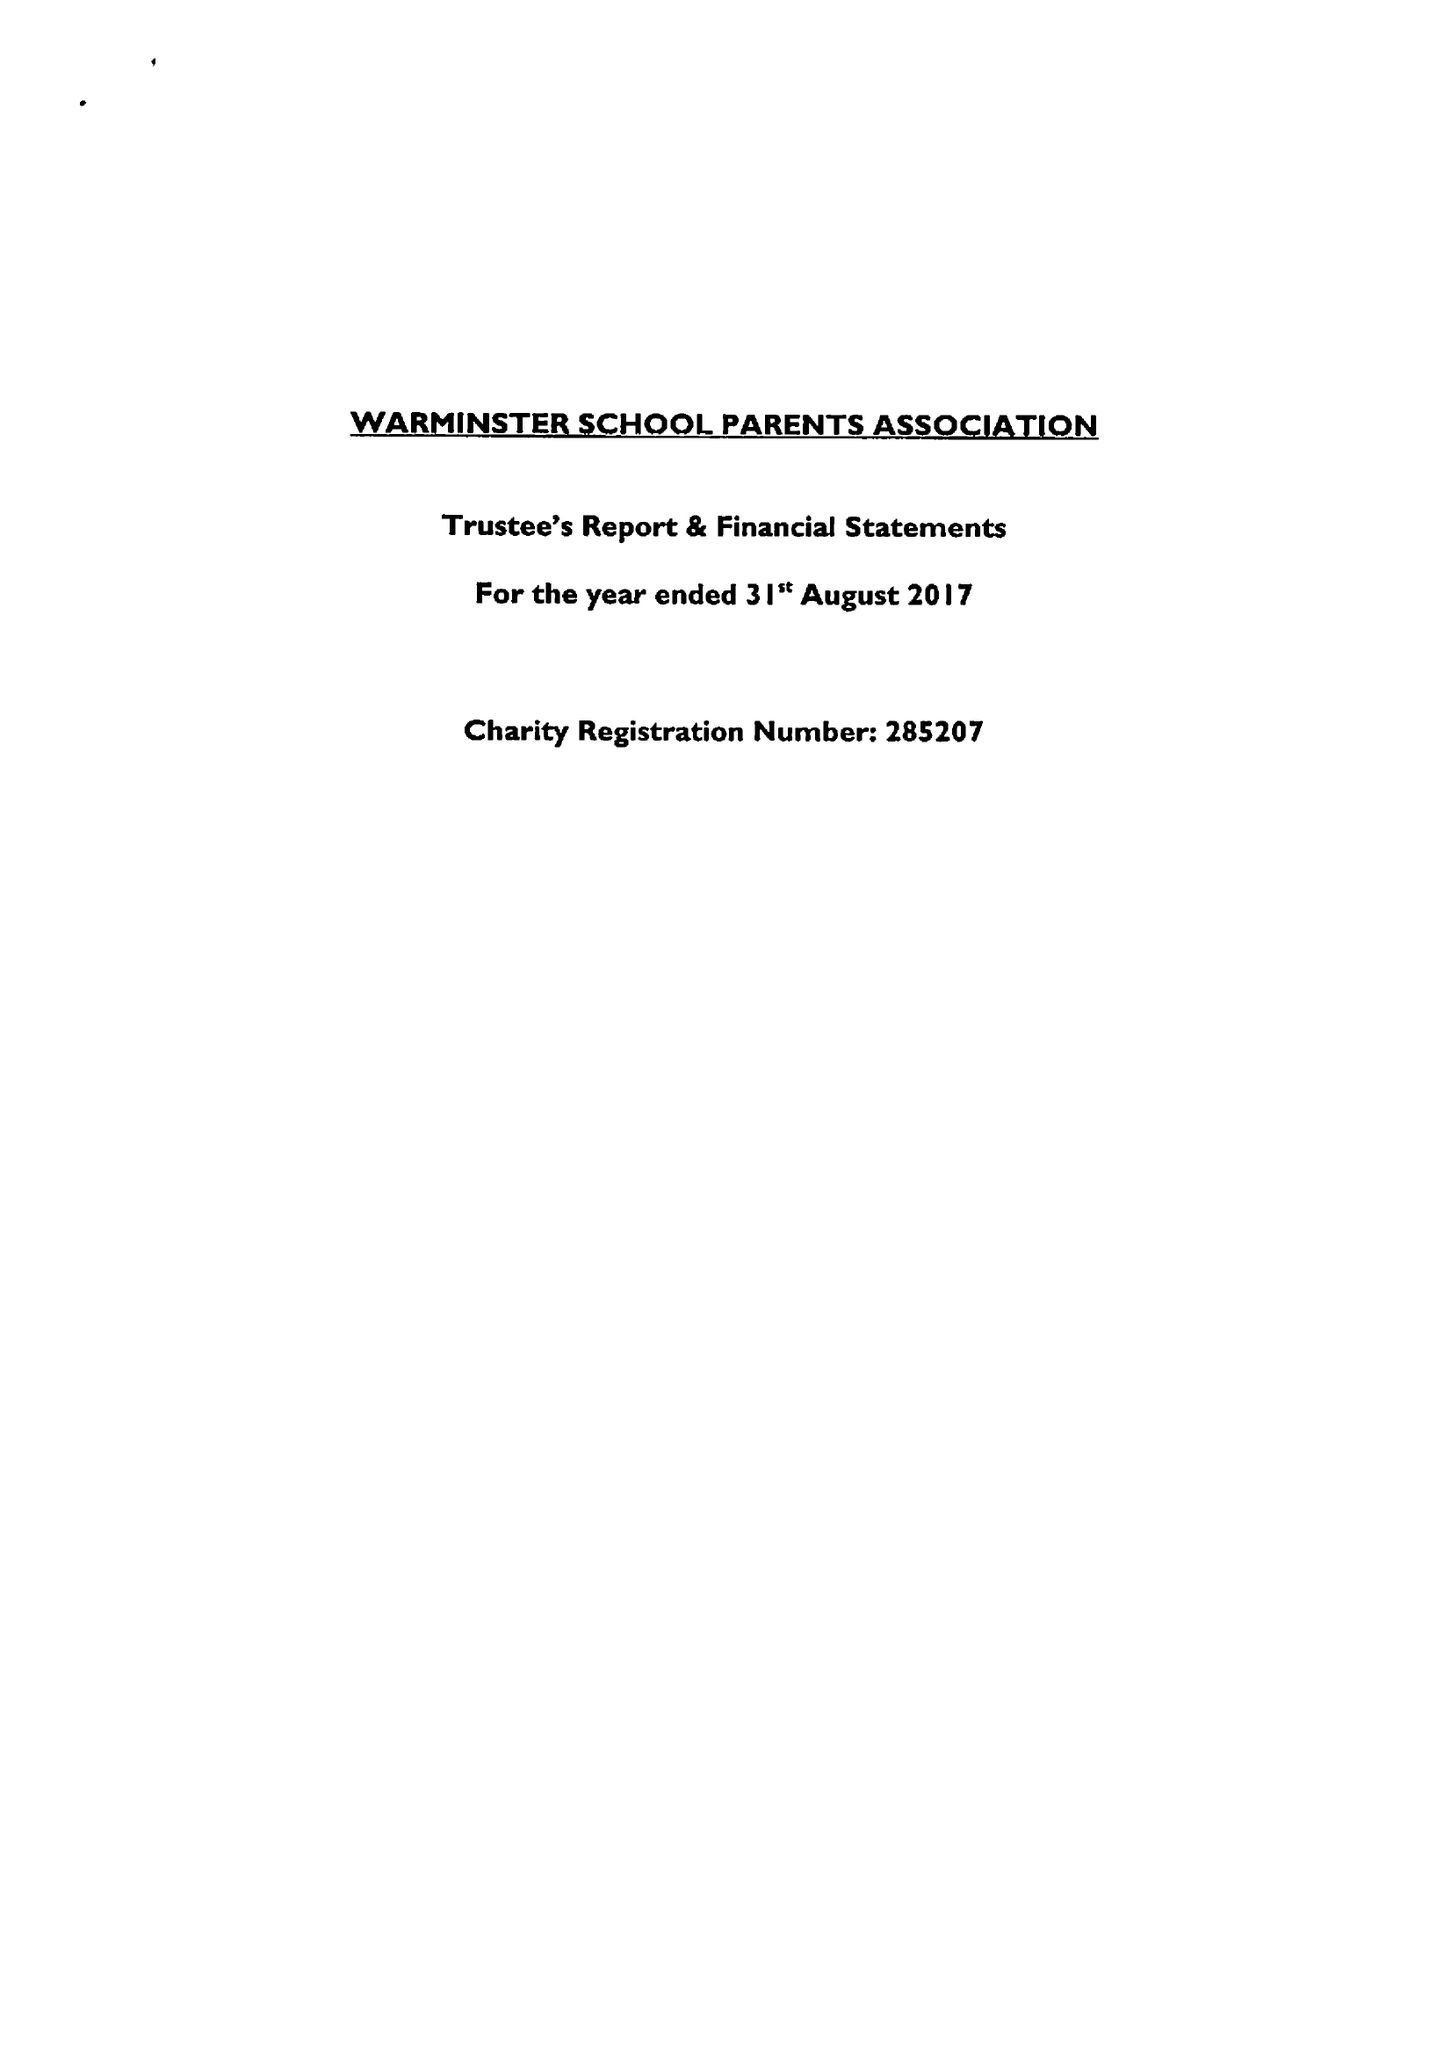What is the value for the income_annually_in_british_pounds?
Answer the question using a single word or phrase. 30395.00 